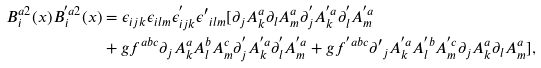<formula> <loc_0><loc_0><loc_500><loc_500>B ^ { a 2 } _ { i } ( x ) B ^ { ^ { \prime } a 2 } _ { i } ( x ) & = \epsilon _ { i j k } \epsilon _ { i l m } \epsilon ^ { ^ { \prime } } _ { i j k } \epsilon { ^ { \prime } } _ { i l m } [ \partial _ { j } A ^ { a } _ { k } \partial _ { l } A ^ { a } _ { m } \partial ^ { ^ { \prime } } _ { j } A ^ { ^ { \prime } a } _ { k } \partial ^ { ^ { \prime } } _ { l } A ^ { ^ { \prime } a } _ { m } \\ & + g f ^ { a b c } \partial _ { j } A ^ { a } _ { k } A ^ { b } _ { l } A ^ { c } _ { m } \partial ^ { ^ { \prime } } _ { j } A ^ { ^ { \prime } a } _ { k } \partial ^ { ^ { \prime } } _ { l } A ^ { ^ { \prime } a } _ { m } + g f ^ { ^ { \prime } a b c } \partial { ^ { \prime } } _ { j } A ^ { ^ { \prime } a } _ { k } A ^ { ^ { \prime } b } _ { l } A ^ { ^ { \prime } c } _ { m } \partial _ { j } A ^ { a } _ { k } \partial _ { l } A ^ { a } _ { m } ] ,</formula> 